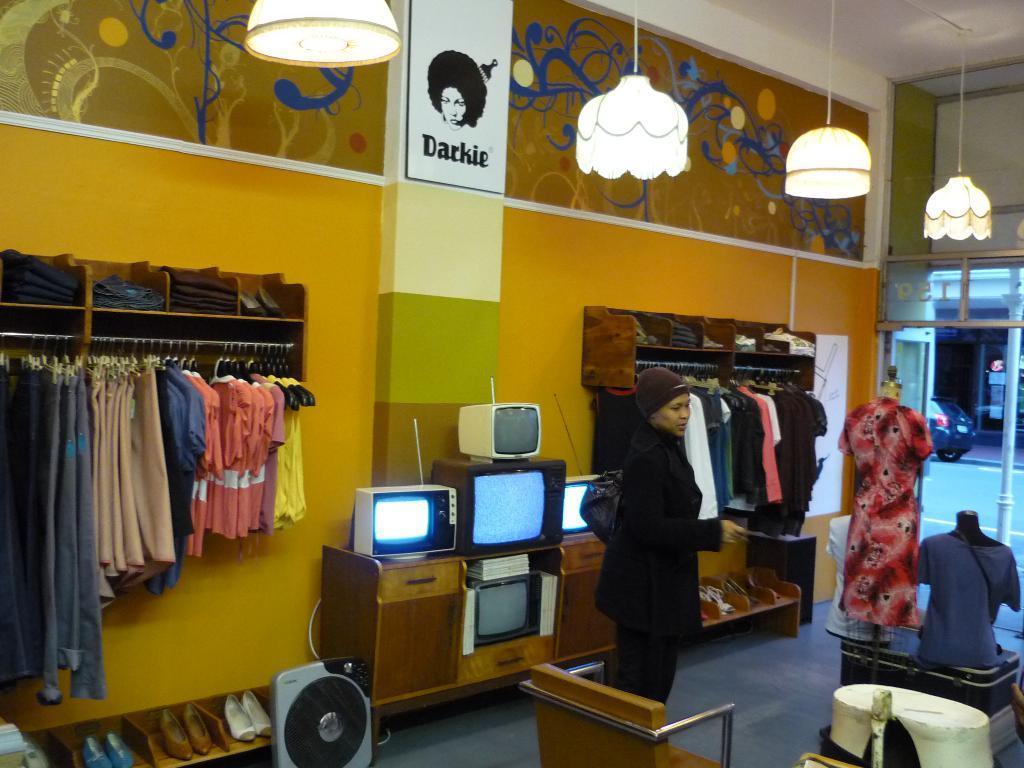Please provide a concise description of this image. There are group of dresses attached to the hanger and there are some televisions in middle of them and there is a person standing in front of television. 